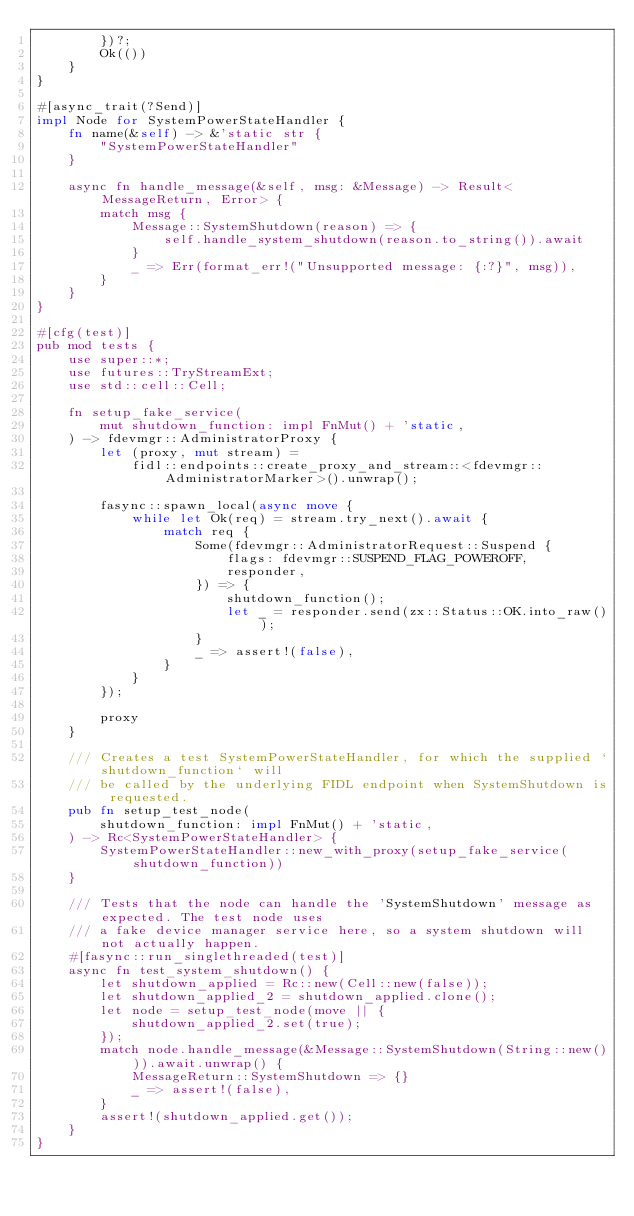<code> <loc_0><loc_0><loc_500><loc_500><_Rust_>        })?;
        Ok(())
    }
}

#[async_trait(?Send)]
impl Node for SystemPowerStateHandler {
    fn name(&self) -> &'static str {
        "SystemPowerStateHandler"
    }

    async fn handle_message(&self, msg: &Message) -> Result<MessageReturn, Error> {
        match msg {
            Message::SystemShutdown(reason) => {
                self.handle_system_shutdown(reason.to_string()).await
            }
            _ => Err(format_err!("Unsupported message: {:?}", msg)),
        }
    }
}

#[cfg(test)]
pub mod tests {
    use super::*;
    use futures::TryStreamExt;
    use std::cell::Cell;

    fn setup_fake_service(
        mut shutdown_function: impl FnMut() + 'static,
    ) -> fdevmgr::AdministratorProxy {
        let (proxy, mut stream) =
            fidl::endpoints::create_proxy_and_stream::<fdevmgr::AdministratorMarker>().unwrap();

        fasync::spawn_local(async move {
            while let Ok(req) = stream.try_next().await {
                match req {
                    Some(fdevmgr::AdministratorRequest::Suspend {
                        flags: fdevmgr::SUSPEND_FLAG_POWEROFF,
                        responder,
                    }) => {
                        shutdown_function();
                        let _ = responder.send(zx::Status::OK.into_raw());
                    }
                    _ => assert!(false),
                }
            }
        });

        proxy
    }

    /// Creates a test SystemPowerStateHandler, for which the supplied `shutdown_function` will
    /// be called by the underlying FIDL endpoint when SystemShutdown is requested.
    pub fn setup_test_node(
        shutdown_function: impl FnMut() + 'static,
    ) -> Rc<SystemPowerStateHandler> {
        SystemPowerStateHandler::new_with_proxy(setup_fake_service(shutdown_function))
    }

    /// Tests that the node can handle the 'SystemShutdown' message as expected. The test node uses
    /// a fake device manager service here, so a system shutdown will not actually happen.
    #[fasync::run_singlethreaded(test)]
    async fn test_system_shutdown() {
        let shutdown_applied = Rc::new(Cell::new(false));
        let shutdown_applied_2 = shutdown_applied.clone();
        let node = setup_test_node(move || {
            shutdown_applied_2.set(true);
        });
        match node.handle_message(&Message::SystemShutdown(String::new())).await.unwrap() {
            MessageReturn::SystemShutdown => {}
            _ => assert!(false),
        }
        assert!(shutdown_applied.get());
    }
}
</code> 